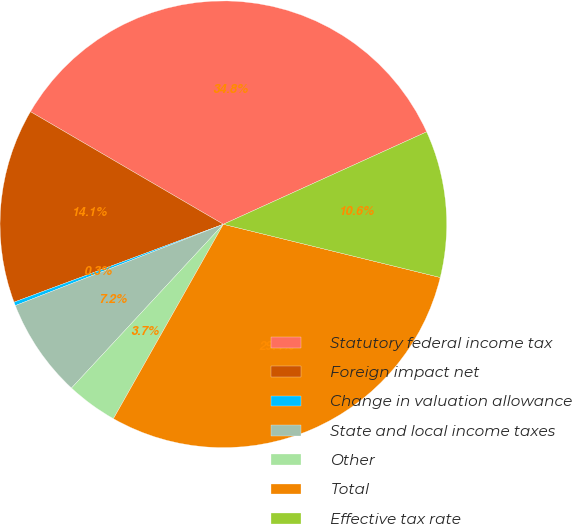Convert chart. <chart><loc_0><loc_0><loc_500><loc_500><pie_chart><fcel>Statutory federal income tax<fcel>Foreign impact net<fcel>Change in valuation allowance<fcel>State and local income taxes<fcel>Other<fcel>Total<fcel>Effective tax rate<nl><fcel>34.8%<fcel>14.08%<fcel>0.26%<fcel>7.17%<fcel>3.71%<fcel>29.36%<fcel>10.62%<nl></chart> 